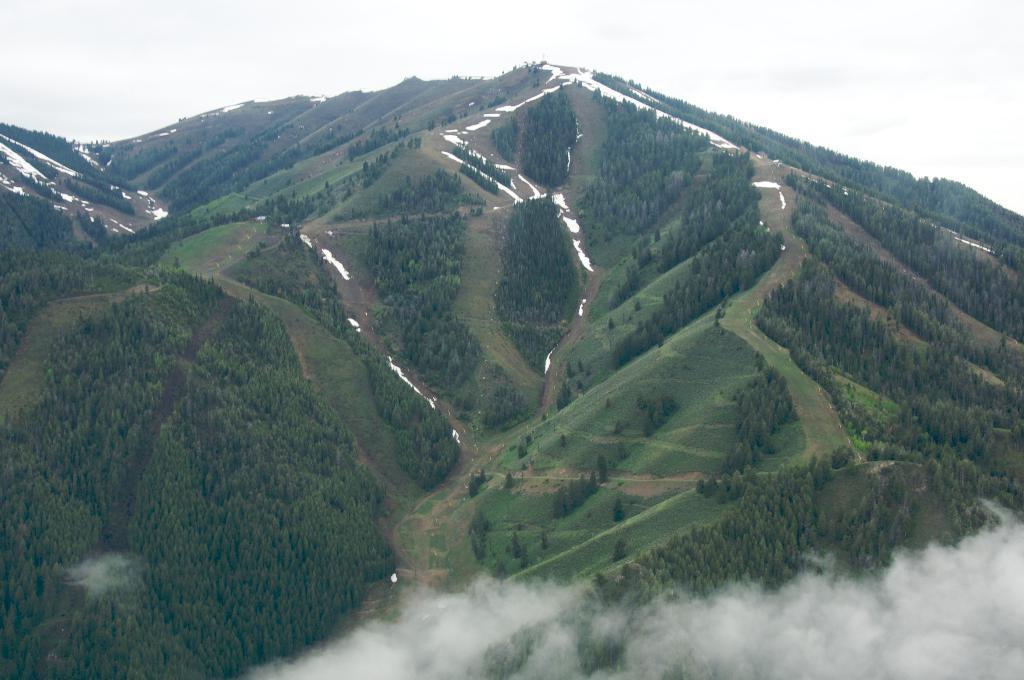Could you give a brief overview of what you see in this image? We can see there are some trees on the mountain in the middle of this image, and there is a sky at the top of this image. 